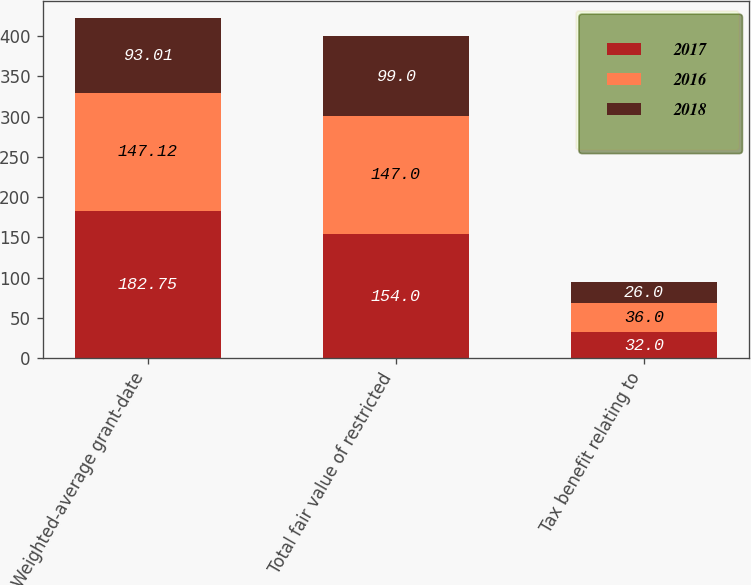<chart> <loc_0><loc_0><loc_500><loc_500><stacked_bar_chart><ecel><fcel>Weighted-average grant-date<fcel>Total fair value of restricted<fcel>Tax benefit relating to<nl><fcel>2017<fcel>182.75<fcel>154<fcel>32<nl><fcel>2016<fcel>147.12<fcel>147<fcel>36<nl><fcel>2018<fcel>93.01<fcel>99<fcel>26<nl></chart> 